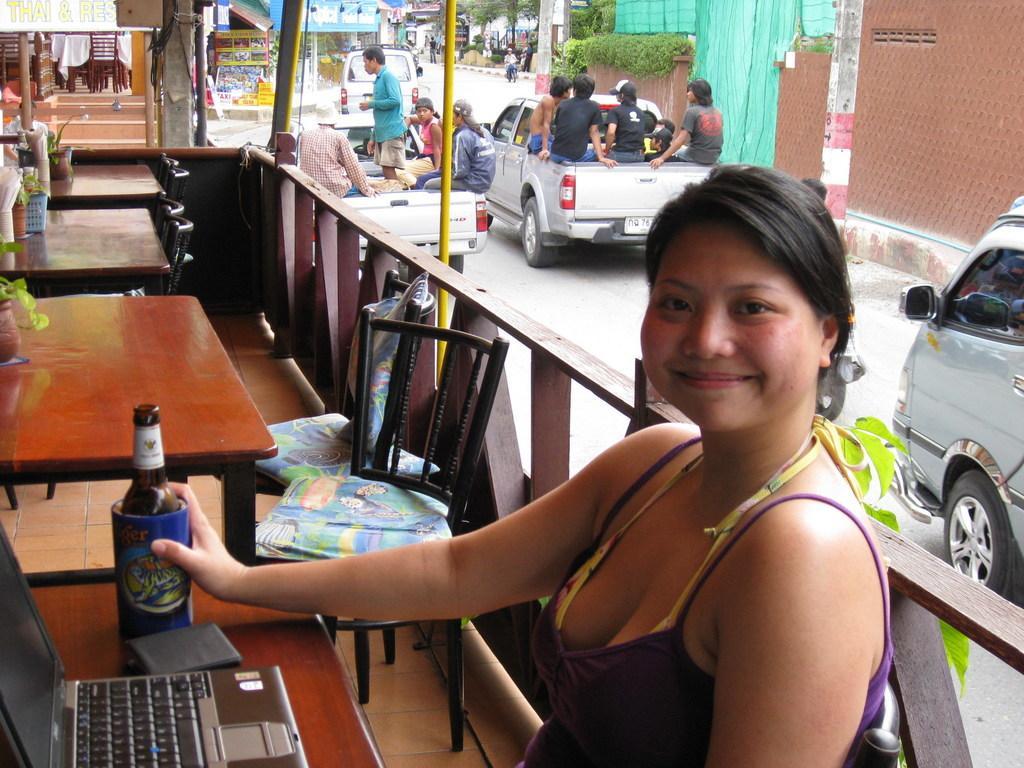In one or two sentences, can you explain what this image depicts? In the image we can see there is a woman who is sitting on chair and on table there is laptop and a wine bottle and at the back people are sitting on the car. 